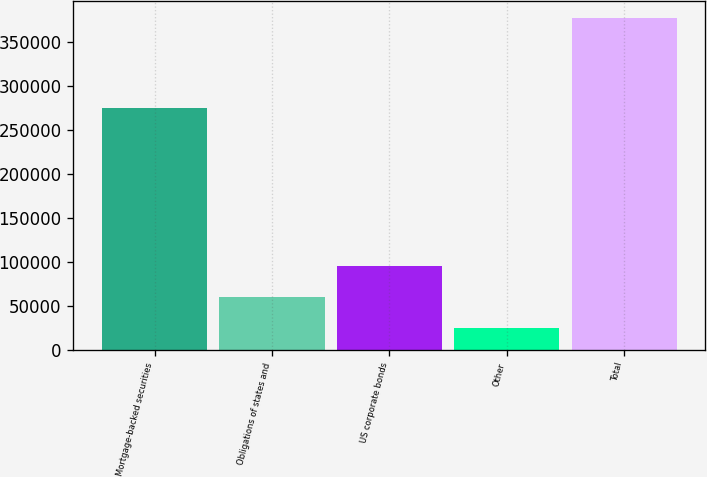Convert chart. <chart><loc_0><loc_0><loc_500><loc_500><bar_chart><fcel>Mortgage-backed securities<fcel>Obligations of states and<fcel>US corporate bonds<fcel>Other<fcel>Total<nl><fcel>274321<fcel>59673.7<fcel>94901.4<fcel>24446<fcel>376723<nl></chart> 